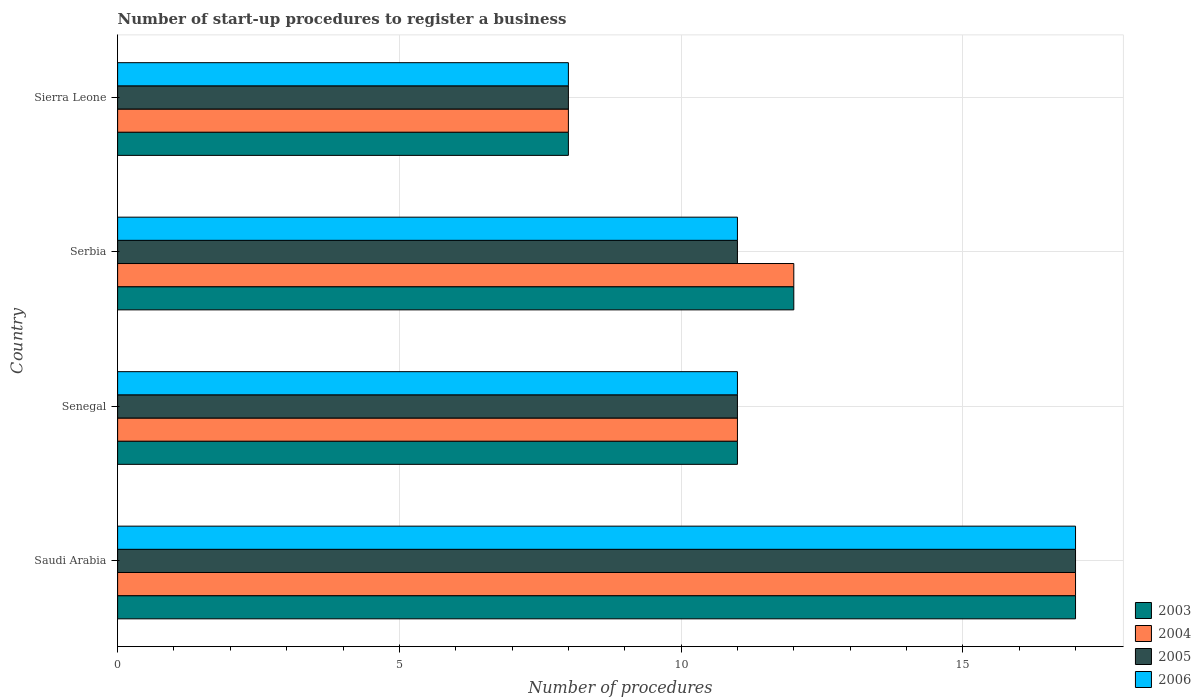How many different coloured bars are there?
Offer a very short reply. 4. How many groups of bars are there?
Your answer should be compact. 4. Are the number of bars on each tick of the Y-axis equal?
Your response must be concise. Yes. How many bars are there on the 1st tick from the bottom?
Offer a terse response. 4. What is the label of the 3rd group of bars from the top?
Keep it short and to the point. Senegal. In how many cases, is the number of bars for a given country not equal to the number of legend labels?
Your answer should be compact. 0. What is the number of procedures required to register a business in 2006 in Senegal?
Provide a succinct answer. 11. Across all countries, what is the maximum number of procedures required to register a business in 2006?
Offer a terse response. 17. Across all countries, what is the minimum number of procedures required to register a business in 2004?
Ensure brevity in your answer.  8. In which country was the number of procedures required to register a business in 2005 maximum?
Provide a succinct answer. Saudi Arabia. In which country was the number of procedures required to register a business in 2003 minimum?
Provide a succinct answer. Sierra Leone. What is the difference between the number of procedures required to register a business in 2005 in Serbia and the number of procedures required to register a business in 2004 in Senegal?
Offer a very short reply. 0. What is the average number of procedures required to register a business in 2003 per country?
Ensure brevity in your answer.  12. What is the difference between the number of procedures required to register a business in 2005 and number of procedures required to register a business in 2003 in Serbia?
Your answer should be very brief. -1. In how many countries, is the number of procedures required to register a business in 2006 greater than 7 ?
Your answer should be very brief. 4. Is it the case that in every country, the sum of the number of procedures required to register a business in 2006 and number of procedures required to register a business in 2003 is greater than the sum of number of procedures required to register a business in 2005 and number of procedures required to register a business in 2004?
Provide a succinct answer. No. Is it the case that in every country, the sum of the number of procedures required to register a business in 2006 and number of procedures required to register a business in 2004 is greater than the number of procedures required to register a business in 2003?
Provide a succinct answer. Yes. How many bars are there?
Make the answer very short. 16. Are all the bars in the graph horizontal?
Your answer should be very brief. Yes. Does the graph contain any zero values?
Provide a succinct answer. No. Does the graph contain grids?
Provide a succinct answer. Yes. How are the legend labels stacked?
Ensure brevity in your answer.  Vertical. What is the title of the graph?
Offer a very short reply. Number of start-up procedures to register a business. What is the label or title of the X-axis?
Offer a terse response. Number of procedures. What is the label or title of the Y-axis?
Offer a very short reply. Country. What is the Number of procedures in 2003 in Saudi Arabia?
Make the answer very short. 17. What is the Number of procedures of 2006 in Saudi Arabia?
Keep it short and to the point. 17. What is the Number of procedures of 2004 in Senegal?
Provide a succinct answer. 11. What is the Number of procedures of 2005 in Senegal?
Offer a very short reply. 11. What is the Number of procedures in 2005 in Serbia?
Provide a short and direct response. 11. What is the Number of procedures of 2005 in Sierra Leone?
Make the answer very short. 8. Across all countries, what is the maximum Number of procedures of 2003?
Make the answer very short. 17. Across all countries, what is the maximum Number of procedures in 2004?
Keep it short and to the point. 17. Across all countries, what is the maximum Number of procedures in 2005?
Offer a terse response. 17. Across all countries, what is the minimum Number of procedures of 2004?
Give a very brief answer. 8. Across all countries, what is the minimum Number of procedures of 2005?
Provide a short and direct response. 8. Across all countries, what is the minimum Number of procedures of 2006?
Keep it short and to the point. 8. What is the total Number of procedures of 2003 in the graph?
Provide a succinct answer. 48. What is the total Number of procedures in 2006 in the graph?
Offer a terse response. 47. What is the difference between the Number of procedures in 2004 in Saudi Arabia and that in Senegal?
Your answer should be very brief. 6. What is the difference between the Number of procedures in 2003 in Saudi Arabia and that in Serbia?
Your response must be concise. 5. What is the difference between the Number of procedures in 2005 in Saudi Arabia and that in Serbia?
Ensure brevity in your answer.  6. What is the difference between the Number of procedures of 2006 in Saudi Arabia and that in Serbia?
Offer a very short reply. 6. What is the difference between the Number of procedures in 2003 in Saudi Arabia and that in Sierra Leone?
Give a very brief answer. 9. What is the difference between the Number of procedures of 2005 in Saudi Arabia and that in Sierra Leone?
Ensure brevity in your answer.  9. What is the difference between the Number of procedures in 2006 in Saudi Arabia and that in Sierra Leone?
Offer a very short reply. 9. What is the difference between the Number of procedures in 2003 in Senegal and that in Serbia?
Your answer should be compact. -1. What is the difference between the Number of procedures in 2004 in Senegal and that in Serbia?
Your answer should be very brief. -1. What is the difference between the Number of procedures of 2005 in Senegal and that in Serbia?
Offer a very short reply. 0. What is the difference between the Number of procedures of 2003 in Senegal and that in Sierra Leone?
Offer a terse response. 3. What is the difference between the Number of procedures in 2006 in Senegal and that in Sierra Leone?
Ensure brevity in your answer.  3. What is the difference between the Number of procedures of 2006 in Serbia and that in Sierra Leone?
Give a very brief answer. 3. What is the difference between the Number of procedures in 2003 in Saudi Arabia and the Number of procedures in 2004 in Senegal?
Provide a short and direct response. 6. What is the difference between the Number of procedures of 2003 in Saudi Arabia and the Number of procedures of 2005 in Senegal?
Your answer should be compact. 6. What is the difference between the Number of procedures of 2003 in Saudi Arabia and the Number of procedures of 2006 in Senegal?
Ensure brevity in your answer.  6. What is the difference between the Number of procedures of 2004 in Saudi Arabia and the Number of procedures of 2005 in Senegal?
Your response must be concise. 6. What is the difference between the Number of procedures of 2004 in Saudi Arabia and the Number of procedures of 2006 in Senegal?
Make the answer very short. 6. What is the difference between the Number of procedures in 2005 in Saudi Arabia and the Number of procedures in 2006 in Senegal?
Provide a short and direct response. 6. What is the difference between the Number of procedures of 2003 in Saudi Arabia and the Number of procedures of 2005 in Serbia?
Give a very brief answer. 6. What is the difference between the Number of procedures of 2004 in Saudi Arabia and the Number of procedures of 2005 in Serbia?
Ensure brevity in your answer.  6. What is the difference between the Number of procedures of 2003 in Saudi Arabia and the Number of procedures of 2006 in Sierra Leone?
Make the answer very short. 9. What is the difference between the Number of procedures of 2003 in Senegal and the Number of procedures of 2004 in Serbia?
Provide a short and direct response. -1. What is the difference between the Number of procedures of 2003 in Senegal and the Number of procedures of 2005 in Serbia?
Give a very brief answer. 0. What is the difference between the Number of procedures of 2003 in Senegal and the Number of procedures of 2006 in Serbia?
Your response must be concise. 0. What is the difference between the Number of procedures in 2004 in Senegal and the Number of procedures in 2005 in Serbia?
Offer a terse response. 0. What is the difference between the Number of procedures of 2004 in Senegal and the Number of procedures of 2006 in Serbia?
Ensure brevity in your answer.  0. What is the difference between the Number of procedures of 2005 in Senegal and the Number of procedures of 2006 in Serbia?
Offer a terse response. 0. What is the difference between the Number of procedures of 2003 in Senegal and the Number of procedures of 2004 in Sierra Leone?
Offer a terse response. 3. What is the difference between the Number of procedures of 2004 in Senegal and the Number of procedures of 2005 in Sierra Leone?
Offer a very short reply. 3. What is the difference between the Number of procedures in 2004 in Senegal and the Number of procedures in 2006 in Sierra Leone?
Keep it short and to the point. 3. What is the difference between the Number of procedures in 2005 in Senegal and the Number of procedures in 2006 in Sierra Leone?
Your answer should be compact. 3. What is the difference between the Number of procedures in 2003 in Serbia and the Number of procedures in 2006 in Sierra Leone?
Make the answer very short. 4. What is the difference between the Number of procedures in 2004 in Serbia and the Number of procedures in 2005 in Sierra Leone?
Offer a very short reply. 4. What is the difference between the Number of procedures of 2004 in Serbia and the Number of procedures of 2006 in Sierra Leone?
Offer a very short reply. 4. What is the average Number of procedures of 2005 per country?
Your answer should be compact. 11.75. What is the average Number of procedures of 2006 per country?
Keep it short and to the point. 11.75. What is the difference between the Number of procedures in 2003 and Number of procedures in 2005 in Saudi Arabia?
Keep it short and to the point. 0. What is the difference between the Number of procedures of 2004 and Number of procedures of 2006 in Saudi Arabia?
Provide a short and direct response. 0. What is the difference between the Number of procedures in 2005 and Number of procedures in 2006 in Saudi Arabia?
Your answer should be compact. 0. What is the difference between the Number of procedures in 2003 and Number of procedures in 2004 in Senegal?
Provide a succinct answer. 0. What is the difference between the Number of procedures in 2003 and Number of procedures in 2005 in Senegal?
Provide a short and direct response. 0. What is the difference between the Number of procedures of 2004 and Number of procedures of 2006 in Senegal?
Provide a short and direct response. 0. What is the difference between the Number of procedures in 2003 and Number of procedures in 2004 in Serbia?
Your response must be concise. 0. What is the difference between the Number of procedures of 2003 and Number of procedures of 2006 in Serbia?
Provide a succinct answer. 1. What is the difference between the Number of procedures in 2004 and Number of procedures in 2006 in Serbia?
Your answer should be compact. 1. What is the difference between the Number of procedures of 2005 and Number of procedures of 2006 in Serbia?
Give a very brief answer. 0. What is the difference between the Number of procedures in 2003 and Number of procedures in 2004 in Sierra Leone?
Ensure brevity in your answer.  0. What is the difference between the Number of procedures of 2004 and Number of procedures of 2005 in Sierra Leone?
Provide a short and direct response. 0. What is the difference between the Number of procedures of 2005 and Number of procedures of 2006 in Sierra Leone?
Offer a terse response. 0. What is the ratio of the Number of procedures in 2003 in Saudi Arabia to that in Senegal?
Make the answer very short. 1.55. What is the ratio of the Number of procedures of 2004 in Saudi Arabia to that in Senegal?
Give a very brief answer. 1.55. What is the ratio of the Number of procedures of 2005 in Saudi Arabia to that in Senegal?
Keep it short and to the point. 1.55. What is the ratio of the Number of procedures in 2006 in Saudi Arabia to that in Senegal?
Ensure brevity in your answer.  1.55. What is the ratio of the Number of procedures in 2003 in Saudi Arabia to that in Serbia?
Give a very brief answer. 1.42. What is the ratio of the Number of procedures of 2004 in Saudi Arabia to that in Serbia?
Ensure brevity in your answer.  1.42. What is the ratio of the Number of procedures of 2005 in Saudi Arabia to that in Serbia?
Provide a succinct answer. 1.55. What is the ratio of the Number of procedures of 2006 in Saudi Arabia to that in Serbia?
Your answer should be compact. 1.55. What is the ratio of the Number of procedures in 2003 in Saudi Arabia to that in Sierra Leone?
Your response must be concise. 2.12. What is the ratio of the Number of procedures in 2004 in Saudi Arabia to that in Sierra Leone?
Give a very brief answer. 2.12. What is the ratio of the Number of procedures in 2005 in Saudi Arabia to that in Sierra Leone?
Your response must be concise. 2.12. What is the ratio of the Number of procedures in 2006 in Saudi Arabia to that in Sierra Leone?
Give a very brief answer. 2.12. What is the ratio of the Number of procedures in 2004 in Senegal to that in Serbia?
Give a very brief answer. 0.92. What is the ratio of the Number of procedures in 2005 in Senegal to that in Serbia?
Make the answer very short. 1. What is the ratio of the Number of procedures of 2003 in Senegal to that in Sierra Leone?
Your response must be concise. 1.38. What is the ratio of the Number of procedures of 2004 in Senegal to that in Sierra Leone?
Ensure brevity in your answer.  1.38. What is the ratio of the Number of procedures in 2005 in Senegal to that in Sierra Leone?
Give a very brief answer. 1.38. What is the ratio of the Number of procedures in 2006 in Senegal to that in Sierra Leone?
Offer a terse response. 1.38. What is the ratio of the Number of procedures of 2005 in Serbia to that in Sierra Leone?
Give a very brief answer. 1.38. What is the ratio of the Number of procedures of 2006 in Serbia to that in Sierra Leone?
Your response must be concise. 1.38. What is the difference between the highest and the second highest Number of procedures in 2006?
Your response must be concise. 6. What is the difference between the highest and the lowest Number of procedures in 2004?
Offer a very short reply. 9. What is the difference between the highest and the lowest Number of procedures of 2005?
Provide a short and direct response. 9. 